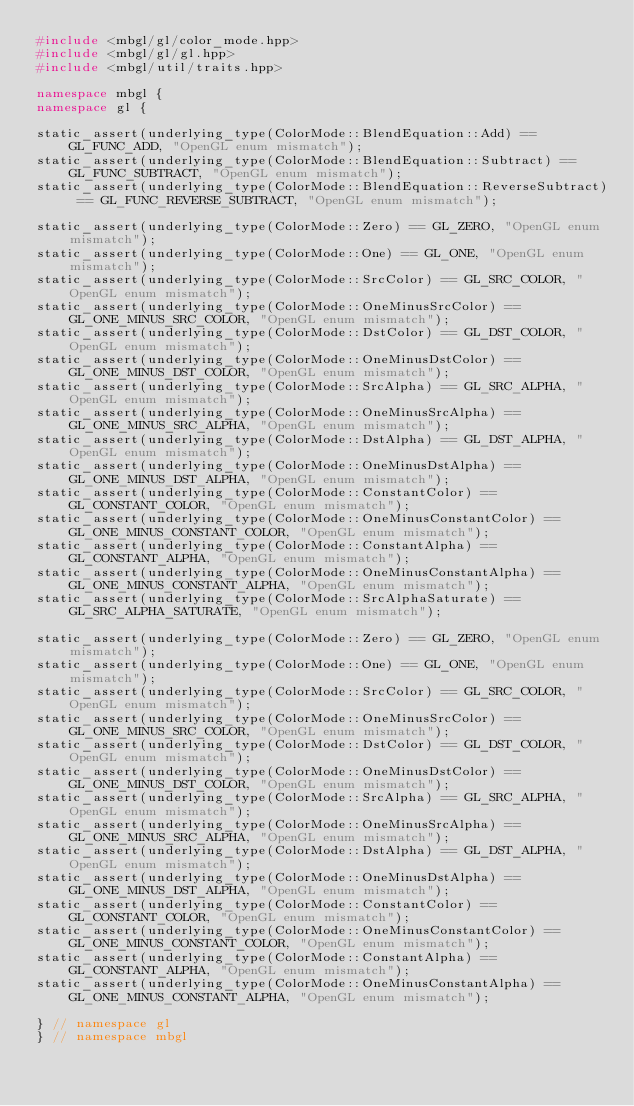Convert code to text. <code><loc_0><loc_0><loc_500><loc_500><_C++_>#include <mbgl/gl/color_mode.hpp>
#include <mbgl/gl/gl.hpp>
#include <mbgl/util/traits.hpp>

namespace mbgl {
namespace gl {

static_assert(underlying_type(ColorMode::BlendEquation::Add) == GL_FUNC_ADD, "OpenGL enum mismatch");
static_assert(underlying_type(ColorMode::BlendEquation::Subtract) == GL_FUNC_SUBTRACT, "OpenGL enum mismatch");
static_assert(underlying_type(ColorMode::BlendEquation::ReverseSubtract) == GL_FUNC_REVERSE_SUBTRACT, "OpenGL enum mismatch");

static_assert(underlying_type(ColorMode::Zero) == GL_ZERO, "OpenGL enum mismatch");
static_assert(underlying_type(ColorMode::One) == GL_ONE, "OpenGL enum mismatch");
static_assert(underlying_type(ColorMode::SrcColor) == GL_SRC_COLOR, "OpenGL enum mismatch");
static_assert(underlying_type(ColorMode::OneMinusSrcColor) == GL_ONE_MINUS_SRC_COLOR, "OpenGL enum mismatch");
static_assert(underlying_type(ColorMode::DstColor) == GL_DST_COLOR, "OpenGL enum mismatch");
static_assert(underlying_type(ColorMode::OneMinusDstColor) == GL_ONE_MINUS_DST_COLOR, "OpenGL enum mismatch");
static_assert(underlying_type(ColorMode::SrcAlpha) == GL_SRC_ALPHA, "OpenGL enum mismatch");
static_assert(underlying_type(ColorMode::OneMinusSrcAlpha) == GL_ONE_MINUS_SRC_ALPHA, "OpenGL enum mismatch");
static_assert(underlying_type(ColorMode::DstAlpha) == GL_DST_ALPHA, "OpenGL enum mismatch");
static_assert(underlying_type(ColorMode::OneMinusDstAlpha) == GL_ONE_MINUS_DST_ALPHA, "OpenGL enum mismatch");
static_assert(underlying_type(ColorMode::ConstantColor) == GL_CONSTANT_COLOR, "OpenGL enum mismatch");
static_assert(underlying_type(ColorMode::OneMinusConstantColor) == GL_ONE_MINUS_CONSTANT_COLOR, "OpenGL enum mismatch");
static_assert(underlying_type(ColorMode::ConstantAlpha) == GL_CONSTANT_ALPHA, "OpenGL enum mismatch");
static_assert(underlying_type(ColorMode::OneMinusConstantAlpha) == GL_ONE_MINUS_CONSTANT_ALPHA, "OpenGL enum mismatch");
static_assert(underlying_type(ColorMode::SrcAlphaSaturate) == GL_SRC_ALPHA_SATURATE, "OpenGL enum mismatch");

static_assert(underlying_type(ColorMode::Zero) == GL_ZERO, "OpenGL enum mismatch");
static_assert(underlying_type(ColorMode::One) == GL_ONE, "OpenGL enum mismatch");
static_assert(underlying_type(ColorMode::SrcColor) == GL_SRC_COLOR, "OpenGL enum mismatch");
static_assert(underlying_type(ColorMode::OneMinusSrcColor) == GL_ONE_MINUS_SRC_COLOR, "OpenGL enum mismatch");
static_assert(underlying_type(ColorMode::DstColor) == GL_DST_COLOR, "OpenGL enum mismatch");
static_assert(underlying_type(ColorMode::OneMinusDstColor) == GL_ONE_MINUS_DST_COLOR, "OpenGL enum mismatch");
static_assert(underlying_type(ColorMode::SrcAlpha) == GL_SRC_ALPHA, "OpenGL enum mismatch");
static_assert(underlying_type(ColorMode::OneMinusSrcAlpha) == GL_ONE_MINUS_SRC_ALPHA, "OpenGL enum mismatch");
static_assert(underlying_type(ColorMode::DstAlpha) == GL_DST_ALPHA, "OpenGL enum mismatch");
static_assert(underlying_type(ColorMode::OneMinusDstAlpha) == GL_ONE_MINUS_DST_ALPHA, "OpenGL enum mismatch");
static_assert(underlying_type(ColorMode::ConstantColor) == GL_CONSTANT_COLOR, "OpenGL enum mismatch");
static_assert(underlying_type(ColorMode::OneMinusConstantColor) == GL_ONE_MINUS_CONSTANT_COLOR, "OpenGL enum mismatch");
static_assert(underlying_type(ColorMode::ConstantAlpha) == GL_CONSTANT_ALPHA, "OpenGL enum mismatch");
static_assert(underlying_type(ColorMode::OneMinusConstantAlpha) == GL_ONE_MINUS_CONSTANT_ALPHA, "OpenGL enum mismatch");

} // namespace gl
} // namespace mbgl
</code> 